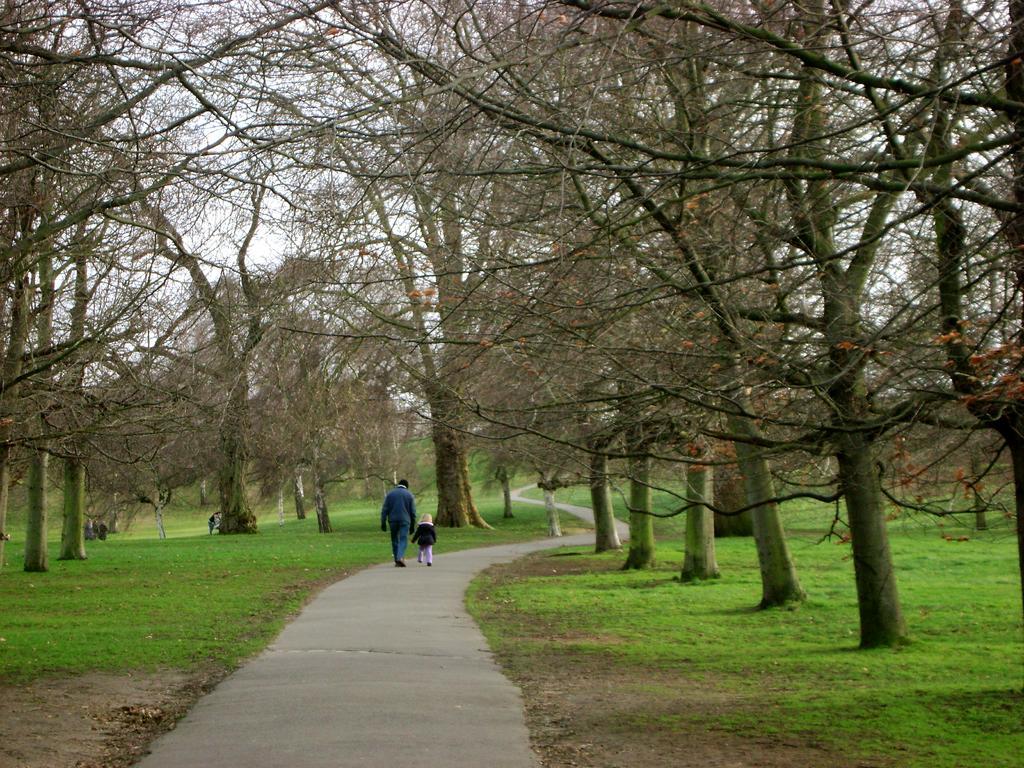In one or two sentences, can you explain what this image depicts? In this image I can see a person and a child are on the road. In the background I can see the grass, trees and the sky. 